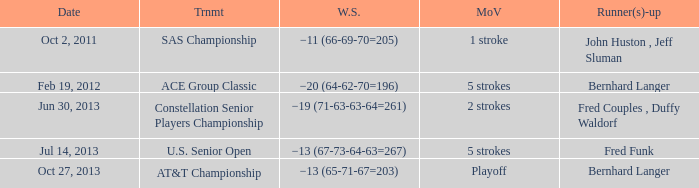Could you parse the entire table? {'header': ['Date', 'Trnmt', 'W.S.', 'MoV', 'Runner(s)-up'], 'rows': [['Oct 2, 2011', 'SAS Championship', '−11 (66-69-70=205)', '1 stroke', 'John Huston , Jeff Sluman'], ['Feb 19, 2012', 'ACE Group Classic', '−20 (64-62-70=196)', '5 strokes', 'Bernhard Langer'], ['Jun 30, 2013', 'Constellation Senior Players Championship', '−19 (71-63-63-64=261)', '2 strokes', 'Fred Couples , Duffy Waldorf'], ['Jul 14, 2013', 'U.S. Senior Open', '−13 (67-73-64-63=267)', '5 strokes', 'Fred Funk'], ['Oct 27, 2013', 'AT&T Championship', '−13 (65-71-67=203)', 'Playoff', 'Bernhard Langer']]} What date features bernhard langer as a runner(s)-up and an event called the at&t championship? Oct 27, 2013. 